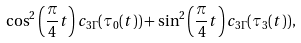<formula> <loc_0><loc_0><loc_500><loc_500>\cos ^ { 2 } \left ( \frac { \pi } { 4 } t \right ) c _ { 3 \Gamma } ( \tau _ { 0 } ( t ) ) + \sin ^ { 2 } \left ( \frac { \pi } { 4 } t \right ) c _ { 3 \Gamma } ( \tau _ { 3 } ( t ) ) ,</formula> 